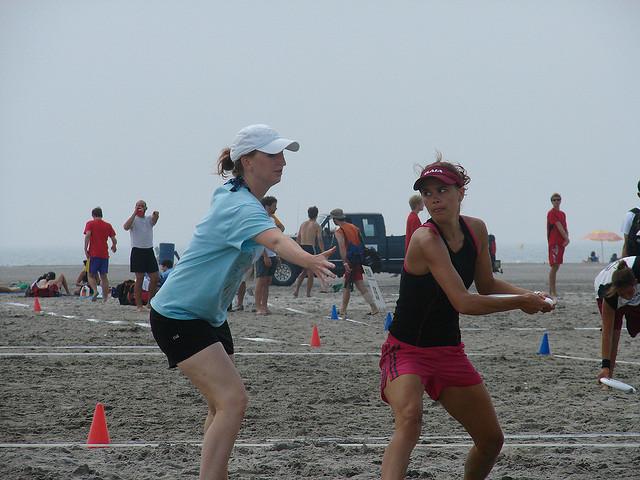What sport is this?
Be succinct. Frisbee. Is this a competition?
Concise answer only. Yes. How can you tell it's not very hot at the beach?
Answer briefly. Overcast. From which hand was the frisbee thrown?
Keep it brief. Right. Are the people getting wet?
Concise answer only. No. Is the boy barefooted?
Write a very short answer. Yes. What is the woman standing behind?
Answer briefly. Another woman. Is the beach busy?
Write a very short answer. Yes. What color are the woman's shorts?
Concise answer only. Pink. What are these women playing with?
Write a very short answer. Frisbee. What are they carrying?
Short answer required. Frisbee. Is this little boy wearing a red shirt?
Write a very short answer. No. What are those triangular shapes on the ground?
Quick response, please. Cones. What is the woman holding?
Be succinct. Frisbee. Are the girls wearing pants?
Keep it brief. No. 